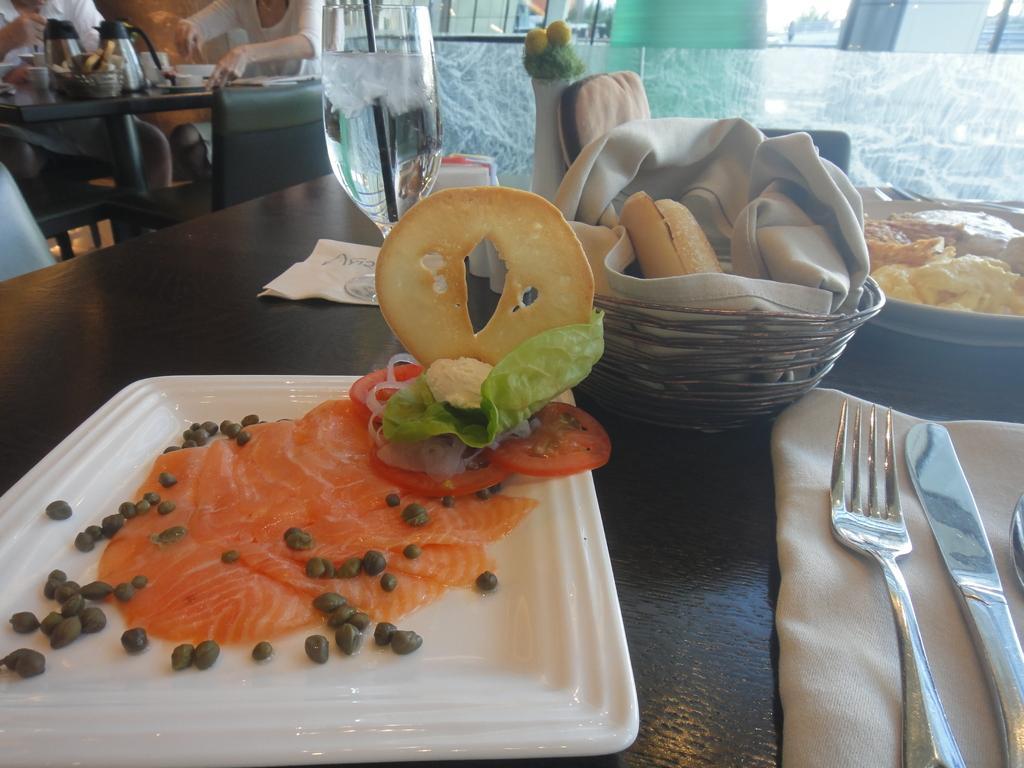Could you give a brief overview of what you see in this image? In this image we can see so many food items are kept on a brown color table. Right side of the image knife, fork and napkin is there. top left corner of the image people are sitting and eating. 